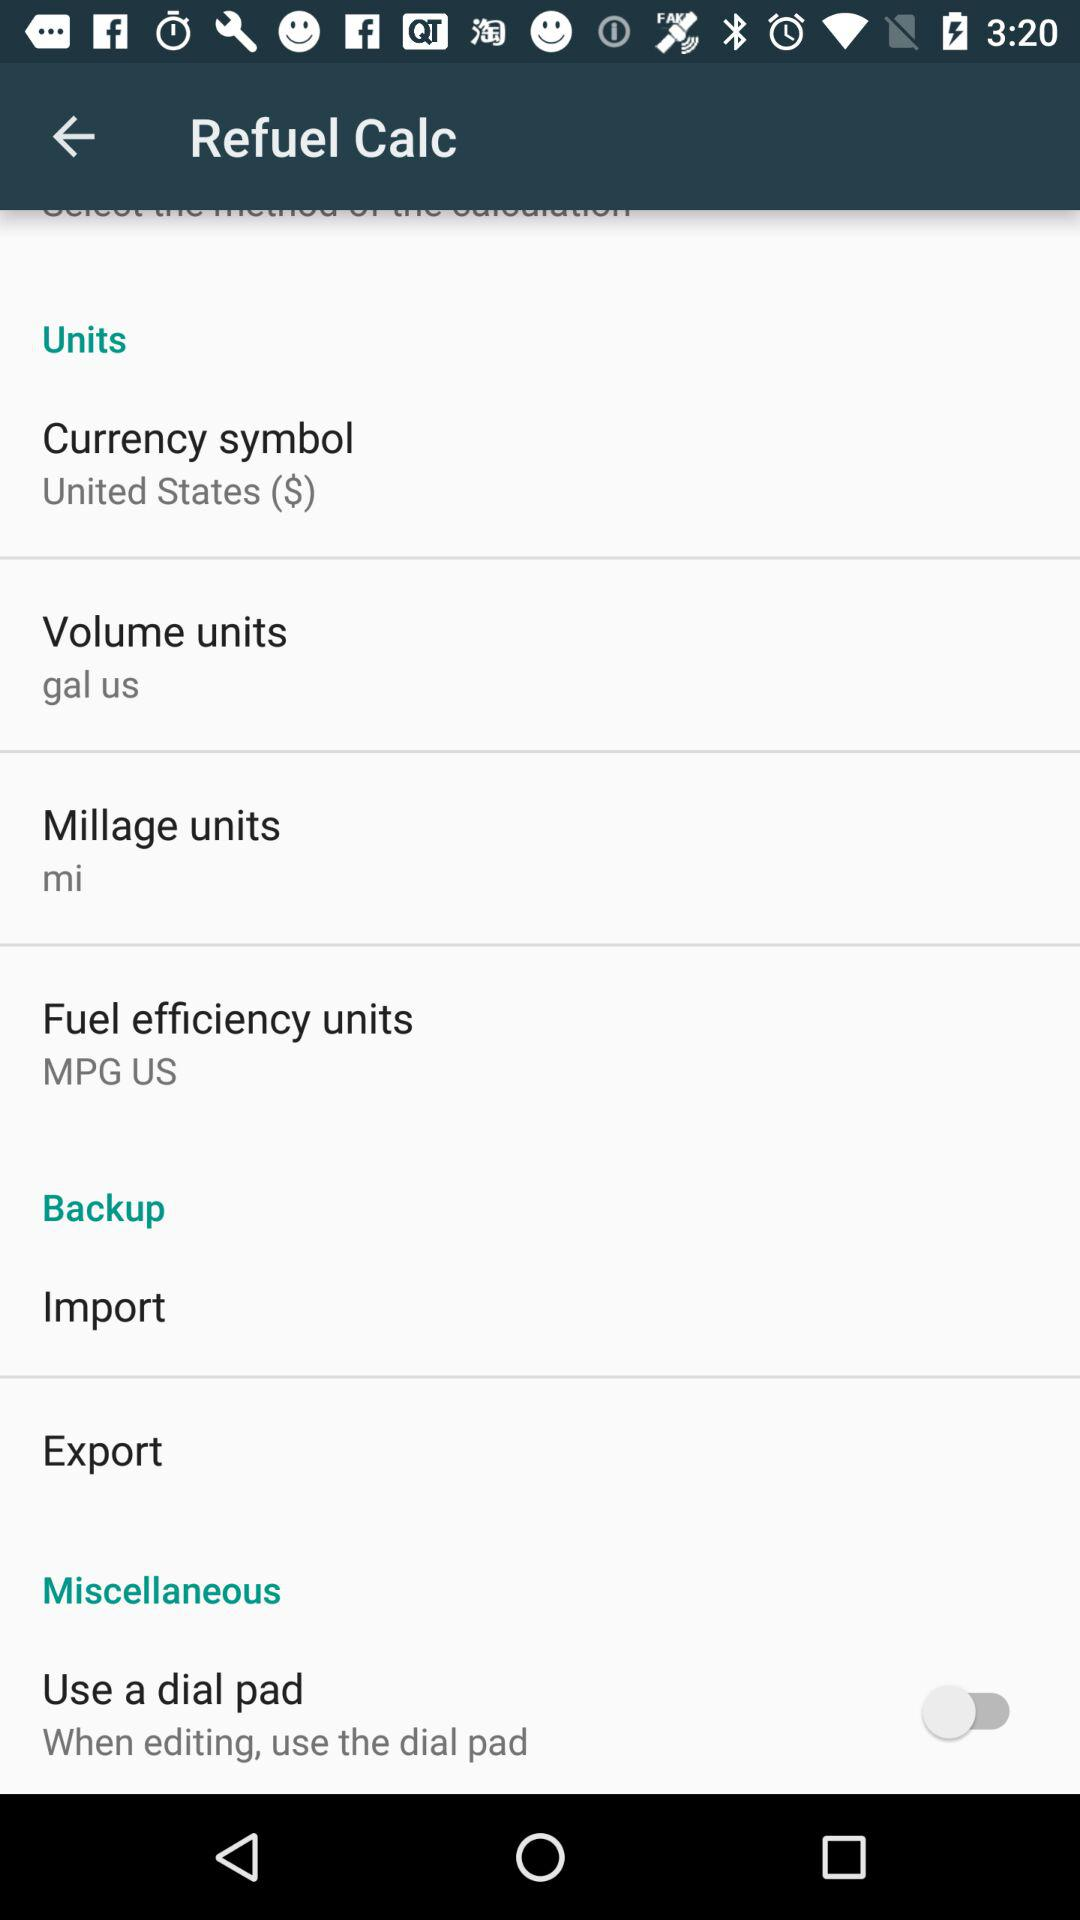What is the status of "Use a dial pad"? The status is "off". 